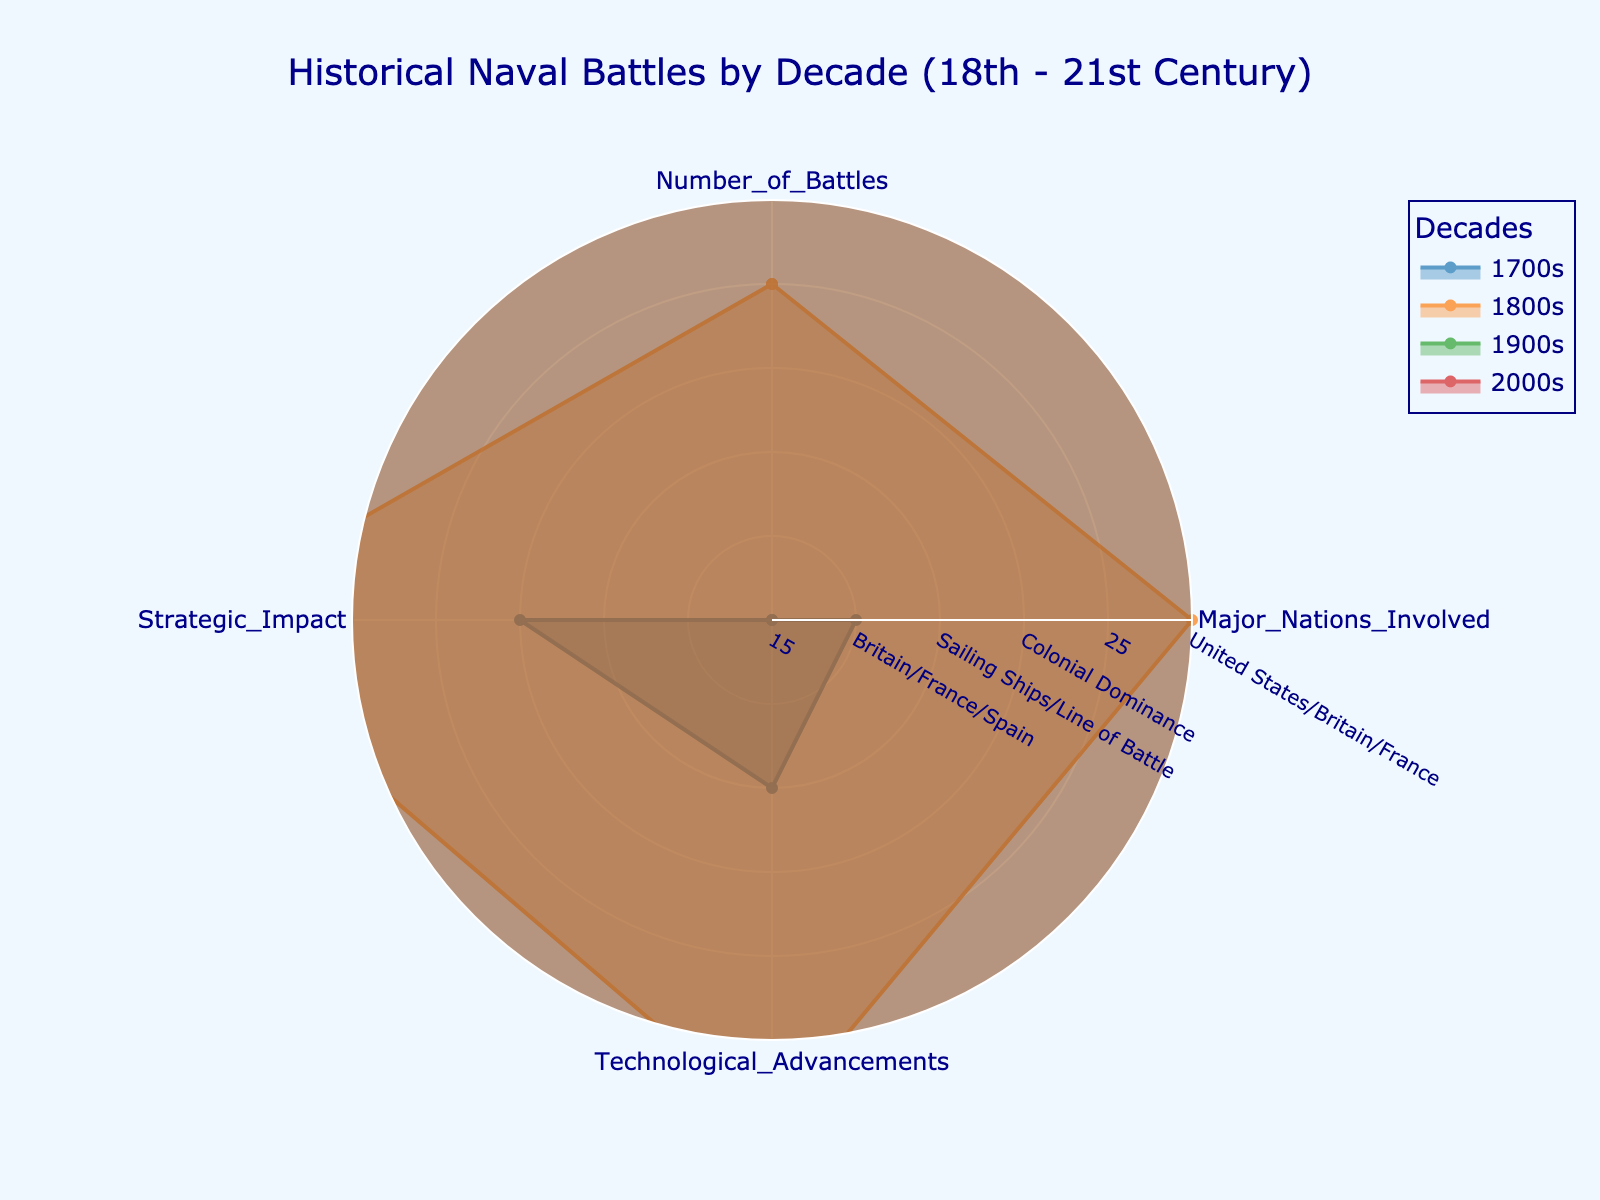what is the title of the plot? The title of the plot is shown at the top and reads 'Historical Naval Battles by Decade (18th - 21st Century)'
Answer: Historical Naval Battles by Decade (18th - 21st Century) how many decades are depicted in the radar chart? Each color region represents a different decade, and the legend indicates there are four decades: 1700s, 1800s, 1900s, and 2000s
Answer: Four which decade has the highest number of battles depicted? The radar chart shows the largest radius value in the 'Number_of_Battles' category for the 1900s
Answer: 1900s in terms of technological advancements, which two decades show the greatest variety? The radar chart indicates two clear separate categories per decade in 'Technological_Advancements', with the 1900s and 2000s showing the most varied technologies (e.g., Aircraft Carriers/Submarines for 1900s and Cyber Warfare/Stealth Technology for 2000s)
Answer: 1900s and 2000s which decade has the most balanced values across all categories? Each decade's values can be compared for balance by examining the uniformity of the radar shape; the 1800s decade appears most balanced as the values are closer across all four categories
Answer: 1800s compare the strategic impact of the 1700s with the 1900s By examining the category 'Strategic_Impact', the 1900s show a larger value span indicating a greater strategic impact than the 1700s
Answer: 1900s calculate the average number of battles across all decades Adding the values from 'Number_of_Battles' across all decades: 15 + 25 + 30 + 12 = 82; thus the average is 82 / 4 = 20.5
Answer: 20.5 which decade involved the fewest major nations? From the 'Major_Nations_Involved' category, the smallest value belongs to the 2000s
Answer: 2000s is the number of battles consistently decreasing or increasing over time? The number of battles first increases from the 1700s (15), to the 1800s (25), peaks in the 1900s (30), and then decreases in the 2000s (12)
Answer: No 